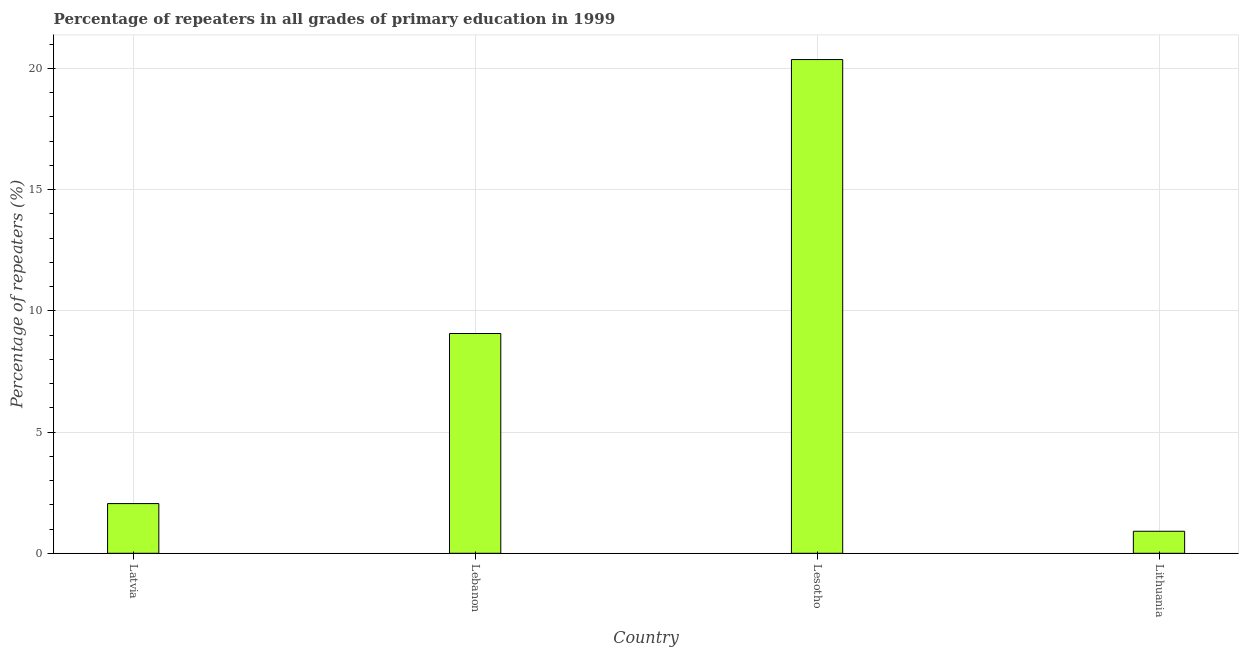Does the graph contain any zero values?
Provide a short and direct response. No. What is the title of the graph?
Ensure brevity in your answer.  Percentage of repeaters in all grades of primary education in 1999. What is the label or title of the Y-axis?
Ensure brevity in your answer.  Percentage of repeaters (%). What is the percentage of repeaters in primary education in Lithuania?
Your answer should be very brief. 0.91. Across all countries, what is the maximum percentage of repeaters in primary education?
Ensure brevity in your answer.  20.37. Across all countries, what is the minimum percentage of repeaters in primary education?
Your answer should be very brief. 0.91. In which country was the percentage of repeaters in primary education maximum?
Offer a terse response. Lesotho. In which country was the percentage of repeaters in primary education minimum?
Keep it short and to the point. Lithuania. What is the sum of the percentage of repeaters in primary education?
Provide a short and direct response. 32.39. What is the difference between the percentage of repeaters in primary education in Latvia and Lesotho?
Provide a short and direct response. -18.32. What is the average percentage of repeaters in primary education per country?
Offer a terse response. 8.1. What is the median percentage of repeaters in primary education?
Offer a very short reply. 5.56. What is the ratio of the percentage of repeaters in primary education in Latvia to that in Lebanon?
Make the answer very short. 0.23. What is the difference between the highest and the second highest percentage of repeaters in primary education?
Your answer should be compact. 11.3. Is the sum of the percentage of repeaters in primary education in Lesotho and Lithuania greater than the maximum percentage of repeaters in primary education across all countries?
Make the answer very short. Yes. What is the difference between the highest and the lowest percentage of repeaters in primary education?
Your response must be concise. 19.46. What is the difference between two consecutive major ticks on the Y-axis?
Offer a very short reply. 5. What is the Percentage of repeaters (%) of Latvia?
Your answer should be compact. 2.05. What is the Percentage of repeaters (%) of Lebanon?
Ensure brevity in your answer.  9.07. What is the Percentage of repeaters (%) of Lesotho?
Your answer should be very brief. 20.37. What is the Percentage of repeaters (%) of Lithuania?
Keep it short and to the point. 0.91. What is the difference between the Percentage of repeaters (%) in Latvia and Lebanon?
Your answer should be very brief. -7.02. What is the difference between the Percentage of repeaters (%) in Latvia and Lesotho?
Give a very brief answer. -18.32. What is the difference between the Percentage of repeaters (%) in Latvia and Lithuania?
Provide a short and direct response. 1.14. What is the difference between the Percentage of repeaters (%) in Lebanon and Lesotho?
Your answer should be very brief. -11.3. What is the difference between the Percentage of repeaters (%) in Lebanon and Lithuania?
Ensure brevity in your answer.  8.16. What is the difference between the Percentage of repeaters (%) in Lesotho and Lithuania?
Ensure brevity in your answer.  19.46. What is the ratio of the Percentage of repeaters (%) in Latvia to that in Lebanon?
Your answer should be compact. 0.23. What is the ratio of the Percentage of repeaters (%) in Latvia to that in Lesotho?
Your answer should be very brief. 0.1. What is the ratio of the Percentage of repeaters (%) in Latvia to that in Lithuania?
Offer a terse response. 2.26. What is the ratio of the Percentage of repeaters (%) in Lebanon to that in Lesotho?
Your answer should be very brief. 0.45. What is the ratio of the Percentage of repeaters (%) in Lebanon to that in Lithuania?
Provide a succinct answer. 9.98. What is the ratio of the Percentage of repeaters (%) in Lesotho to that in Lithuania?
Offer a terse response. 22.41. 